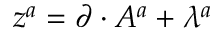Convert formula to latex. <formula><loc_0><loc_0><loc_500><loc_500>{ z } ^ { a } = \partial \cdot A ^ { a } + \lambda ^ { a }</formula> 